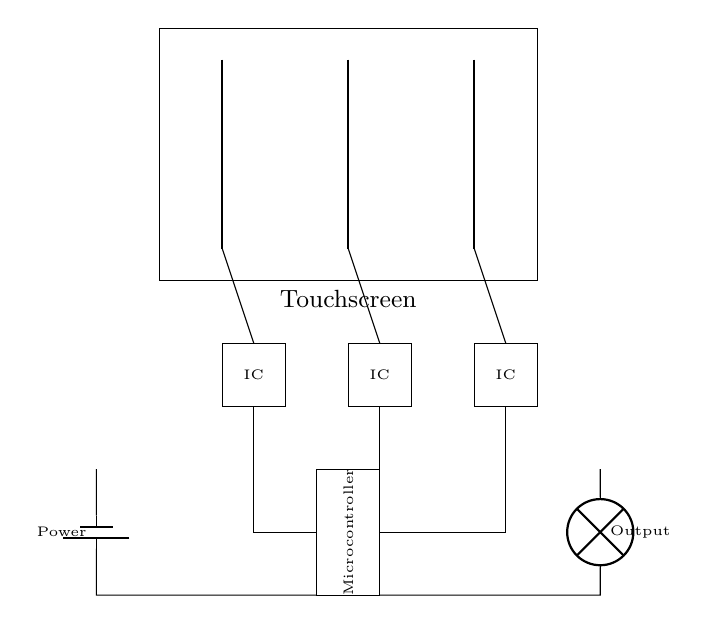What type of technology is used in this touchscreen? The circuit uses capacitive technology to sense touch, as indicated by the electrodes that detect changes in capacitance when a finger approaches.
Answer: capacitive How many sensing electrodes are shown in the circuit? There are three sensing electrodes depicted in the diagram, each represented by vertical lines in the touchscreen area.
Answer: three What is the purpose of the microcontroller in this circuit? The microcontroller processes the signals received from the capacitive sensing ICs and manages the output based on the touch input detected by the sensing electrodes.
Answer: processing signals What is the function of the capacitive sensing ICs? The capacitive sensing ICs detect the changes in capacitance caused by finger touches to the touchscreen, enabling the system to recognize touch inputs.
Answer: detect capacitance Which component provides power to the circuit? A battery provides the required power to the circuit, as represented by the battery symbol in the lower left part of the diagram.
Answer: battery How are the sensing electrodes connected to the ICs? Each sensing electrode is connected to its respective IC through a line that indicates the pathway for the electrical connections.
Answer: through lines What does the output from the microcontroller control? The output from the microcontroller controls a lamp as indicated by the output path leading to a lamp in the circuit diagram.
Answer: lamp 